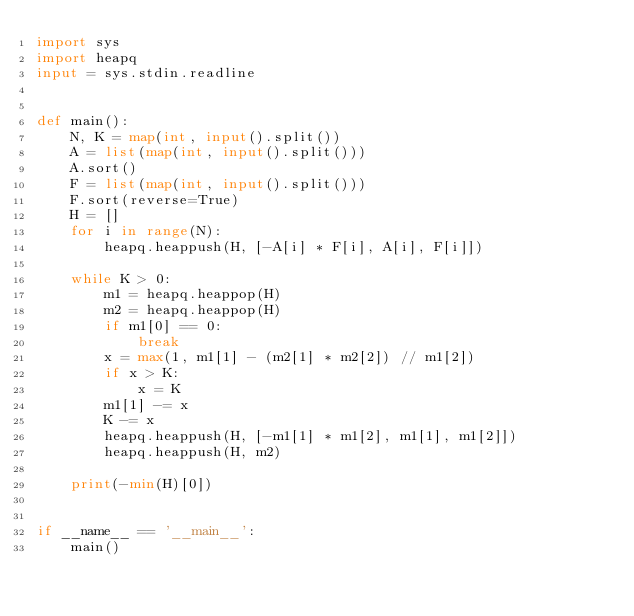<code> <loc_0><loc_0><loc_500><loc_500><_Python_>import sys
import heapq
input = sys.stdin.readline


def main():
    N, K = map(int, input().split())
    A = list(map(int, input().split()))
    A.sort()
    F = list(map(int, input().split()))
    F.sort(reverse=True)
    H = []
    for i in range(N):
        heapq.heappush(H, [-A[i] * F[i], A[i], F[i]])

    while K > 0:
        m1 = heapq.heappop(H)
        m2 = heapq.heappop(H)
        if m1[0] == 0:
            break
        x = max(1, m1[1] - (m2[1] * m2[2]) // m1[2])
        if x > K:
            x = K
        m1[1] -= x
        K -= x
        heapq.heappush(H, [-m1[1] * m1[2], m1[1], m1[2]])
        heapq.heappush(H, m2)

    print(-min(H)[0])


if __name__ == '__main__':
    main()
</code> 